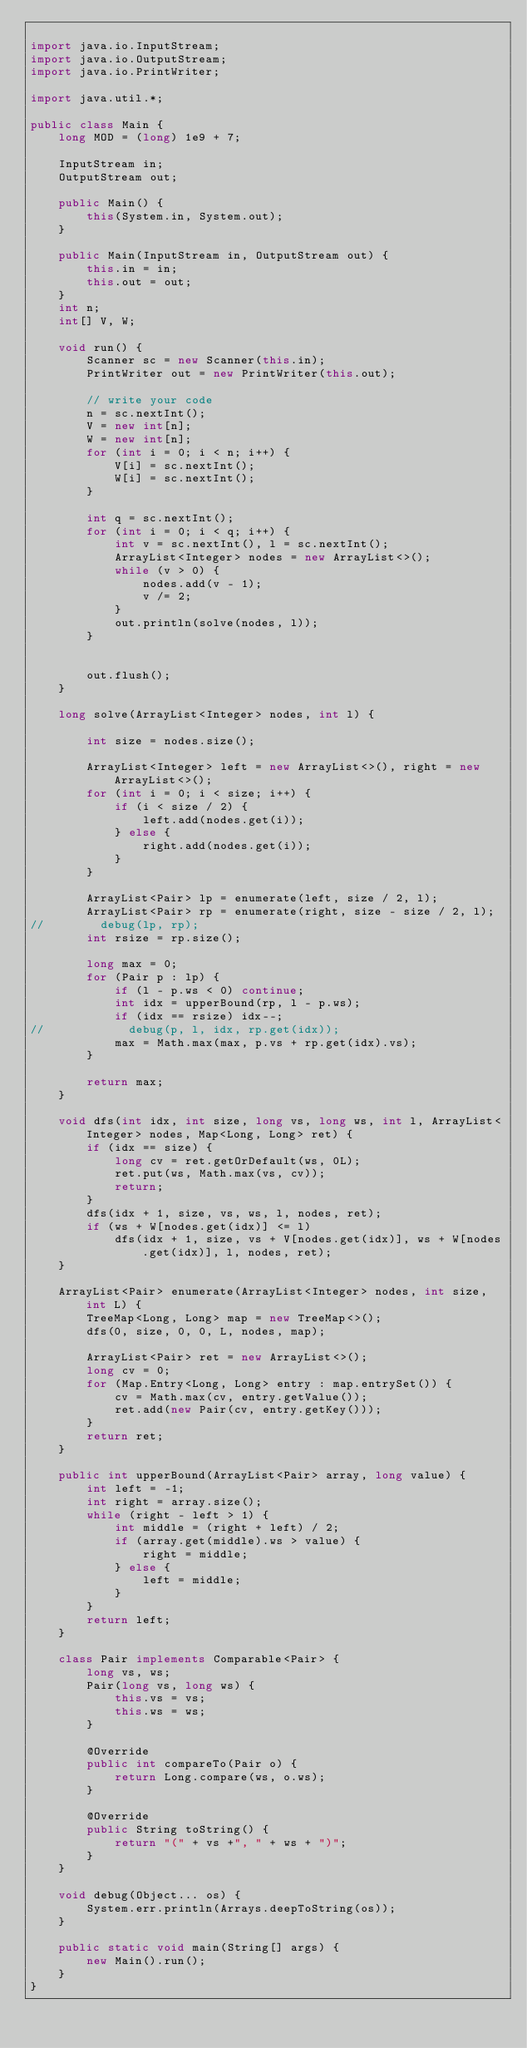<code> <loc_0><loc_0><loc_500><loc_500><_Java_>
import java.io.InputStream;
import java.io.OutputStream;
import java.io.PrintWriter;

import java.util.*;

public class Main {
    long MOD = (long) 1e9 + 7;

    InputStream in;
    OutputStream out;

    public Main() {
        this(System.in, System.out);
    }

    public Main(InputStream in, OutputStream out) {
        this.in = in;
        this.out = out;
    }
    int n;
    int[] V, W;

    void run() {
        Scanner sc = new Scanner(this.in);
        PrintWriter out = new PrintWriter(this.out);

        // write your code
        n = sc.nextInt();
        V = new int[n];
        W = new int[n];
        for (int i = 0; i < n; i++) {
            V[i] = sc.nextInt();
            W[i] = sc.nextInt();
        }

        int q = sc.nextInt();
        for (int i = 0; i < q; i++) {
            int v = sc.nextInt(), l = sc.nextInt();
            ArrayList<Integer> nodes = new ArrayList<>();
            while (v > 0) {
                nodes.add(v - 1);
                v /= 2;
            }
            out.println(solve(nodes, l));
        }


        out.flush();
    }

    long solve(ArrayList<Integer> nodes, int l) {

        int size = nodes.size();

        ArrayList<Integer> left = new ArrayList<>(), right = new ArrayList<>();
        for (int i = 0; i < size; i++) {
            if (i < size / 2) {
                left.add(nodes.get(i));
            } else {
                right.add(nodes.get(i));
            }
        }

        ArrayList<Pair> lp = enumerate(left, size / 2, l);
        ArrayList<Pair> rp = enumerate(right, size - size / 2, l);
//        debug(lp, rp);
        int rsize = rp.size();

        long max = 0;
        for (Pair p : lp) {
            if (l - p.ws < 0) continue;
            int idx = upperBound(rp, l - p.ws);
            if (idx == rsize) idx--;
//            debug(p, l, idx, rp.get(idx));
            max = Math.max(max, p.vs + rp.get(idx).vs);
        }

        return max;
    }

    void dfs(int idx, int size, long vs, long ws, int l, ArrayList<Integer> nodes, Map<Long, Long> ret) {
        if (idx == size) {
            long cv = ret.getOrDefault(ws, 0L);
            ret.put(ws, Math.max(vs, cv));
            return;
        }
        dfs(idx + 1, size, vs, ws, l, nodes, ret);
        if (ws + W[nodes.get(idx)] <= l)
            dfs(idx + 1, size, vs + V[nodes.get(idx)], ws + W[nodes.get(idx)], l, nodes, ret);
    }

    ArrayList<Pair> enumerate(ArrayList<Integer> nodes, int size, int L) {
        TreeMap<Long, Long> map = new TreeMap<>();
        dfs(0, size, 0, 0, L, nodes, map);

        ArrayList<Pair> ret = new ArrayList<>();
        long cv = 0;
        for (Map.Entry<Long, Long> entry : map.entrySet()) {
            cv = Math.max(cv, entry.getValue());
            ret.add(new Pair(cv, entry.getKey()));
        }
        return ret;
    }

    public int upperBound(ArrayList<Pair> array, long value) {
        int left = -1;
        int right = array.size();
        while (right - left > 1) {
            int middle = (right + left) / 2;
            if (array.get(middle).ws > value) {
                right = middle;
            } else {
                left = middle;
            }
        }
        return left;
    }

    class Pair implements Comparable<Pair> {
        long vs, ws;
        Pair(long vs, long ws) {
            this.vs = vs;
            this.ws = ws;
        }

        @Override
        public int compareTo(Pair o) {
            return Long.compare(ws, o.ws);
        }

        @Override
        public String toString() {
            return "(" + vs +", " + ws + ")";
        }
    }

    void debug(Object... os) {
        System.err.println(Arrays.deepToString(os));
    }

    public static void main(String[] args) {
        new Main().run();
    }
}</code> 